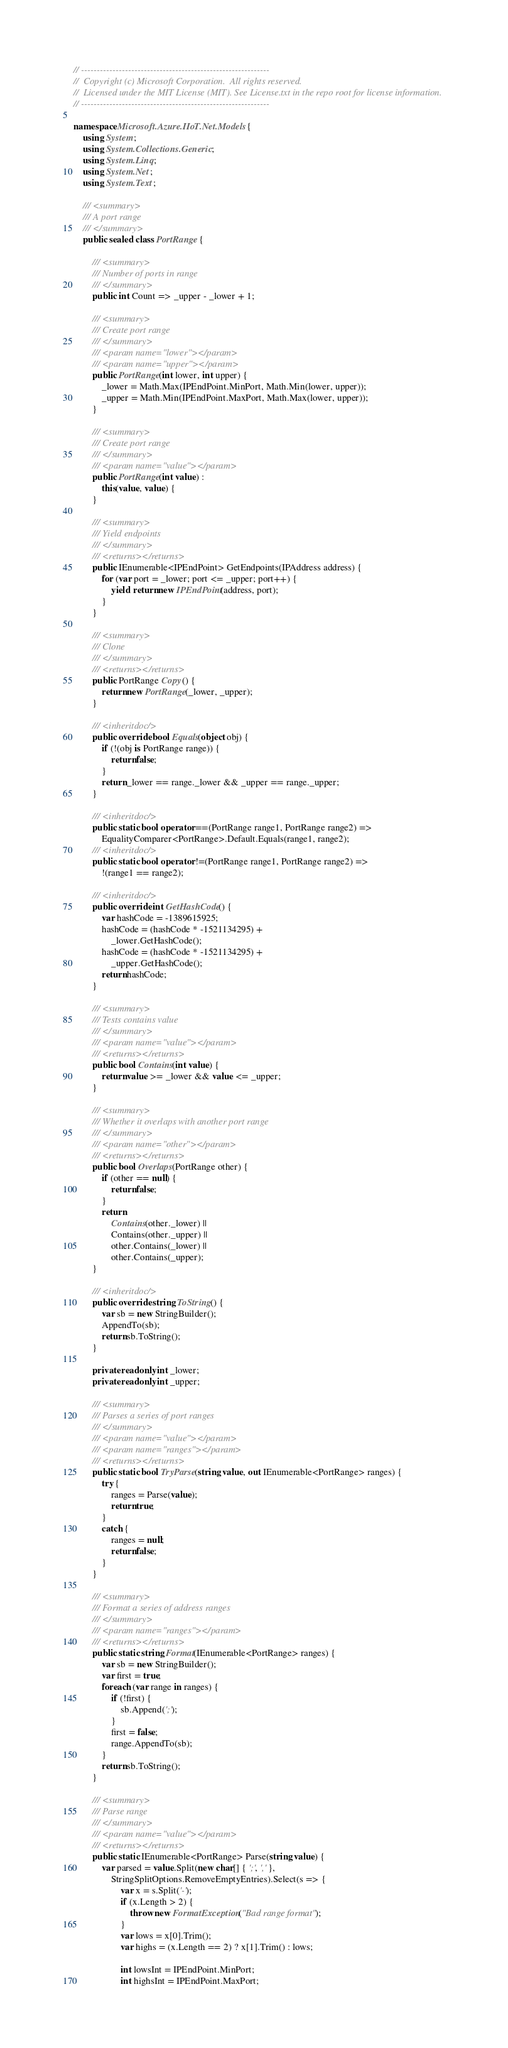<code> <loc_0><loc_0><loc_500><loc_500><_C#_>// ------------------------------------------------------------
//  Copyright (c) Microsoft Corporation.  All rights reserved.
//  Licensed under the MIT License (MIT). See License.txt in the repo root for license information.
// ------------------------------------------------------------

namespace Microsoft.Azure.IIoT.Net.Models {
    using System;
    using System.Collections.Generic;
    using System.Linq;
    using System.Net;
    using System.Text;

    /// <summary>
    /// A port range
    /// </summary>
    public sealed class PortRange {

        /// <summary>
        /// Number of ports in range
        /// </summary>
        public int Count => _upper - _lower + 1;

        /// <summary>
        /// Create port range
        /// </summary>
        /// <param name="lower"></param>
        /// <param name="upper"></param>
        public PortRange(int lower, int upper) {
            _lower = Math.Max(IPEndPoint.MinPort, Math.Min(lower, upper));
            _upper = Math.Min(IPEndPoint.MaxPort, Math.Max(lower, upper));
        }

        /// <summary>
        /// Create port range
        /// </summary>
        /// <param name="value"></param>
        public PortRange(int value) :
            this(value, value) {
        }

        /// <summary>
        /// Yield endpoints
        /// </summary>
        /// <returns></returns>
        public IEnumerable<IPEndPoint> GetEndpoints(IPAddress address) {
            for (var port = _lower; port <= _upper; port++) {
                yield return new IPEndPoint(address, port);
            }
        }

        /// <summary>
        /// Clone
        /// </summary>
        /// <returns></returns>
        public PortRange Copy() {
            return new PortRange(_lower, _upper);
        }

        /// <inheritdoc/>
        public override bool Equals(object obj) {
            if (!(obj is PortRange range)) {
                return false;
            }
            return _lower == range._lower && _upper == range._upper;
        }

        /// <inheritdoc/>
        public static bool operator ==(PortRange range1, PortRange range2) =>
            EqualityComparer<PortRange>.Default.Equals(range1, range2);
        /// <inheritdoc/>
        public static bool operator !=(PortRange range1, PortRange range2) =>
            !(range1 == range2);

        /// <inheritdoc/>
        public override int GetHashCode() {
            var hashCode = -1389615925;
            hashCode = (hashCode * -1521134295) +
                _lower.GetHashCode();
            hashCode = (hashCode * -1521134295) +
                _upper.GetHashCode();
            return hashCode;
        }

        /// <summary>
        /// Tests contains value
        /// </summary>
        /// <param name="value"></param>
        /// <returns></returns>
        public bool Contains(int value) {
            return value >= _lower && value <= _upper;
        }

        /// <summary>
        /// Whether it overlaps with another port range
        /// </summary>
        /// <param name="other"></param>
        /// <returns></returns>
        public bool Overlaps(PortRange other) {
            if (other == null) {
                return false;
            }
            return
                Contains(other._lower) ||
                Contains(other._upper) ||
                other.Contains(_lower) ||
                other.Contains(_upper);
        }

        /// <inheritdoc/>
        public override string ToString() {
            var sb = new StringBuilder();
            AppendTo(sb);
            return sb.ToString();
        }

        private readonly int _lower;
        private readonly int _upper;

        /// <summary>
        /// Parses a series of port ranges
        /// </summary>
        /// <param name="value"></param>
        /// <param name="ranges"></param>
        /// <returns></returns>
        public static bool TryParse(string value, out IEnumerable<PortRange> ranges) {
            try {
                ranges = Parse(value);
                return true;
            }
            catch {
                ranges = null;
                return false;
            }
        }

        /// <summary>
        /// Format a series of address ranges
        /// </summary>
        /// <param name="ranges"></param>
        /// <returns></returns>
        public static string Format(IEnumerable<PortRange> ranges) {
            var sb = new StringBuilder();
            var first = true;
            foreach (var range in ranges) {
                if (!first) {
                    sb.Append(';');
                }
                first = false;
                range.AppendTo(sb);
            }
            return sb.ToString();
        }

        /// <summary>
        /// Parse range
        /// </summary>
        /// <param name="value"></param>
        /// <returns></returns>
        public static IEnumerable<PortRange> Parse(string value) {
            var parsed = value.Split(new char[] { ';', ',' },
                StringSplitOptions.RemoveEmptyEntries).Select(s => {
                    var x = s.Split('-');
                    if (x.Length > 2) {
                        throw new FormatException("Bad range format");
                    }
                    var lows = x[0].Trim();
                    var highs = (x.Length == 2) ? x[1].Trim() : lows;

                    int lowsInt = IPEndPoint.MinPort;
                    int highsInt = IPEndPoint.MaxPort;
</code> 